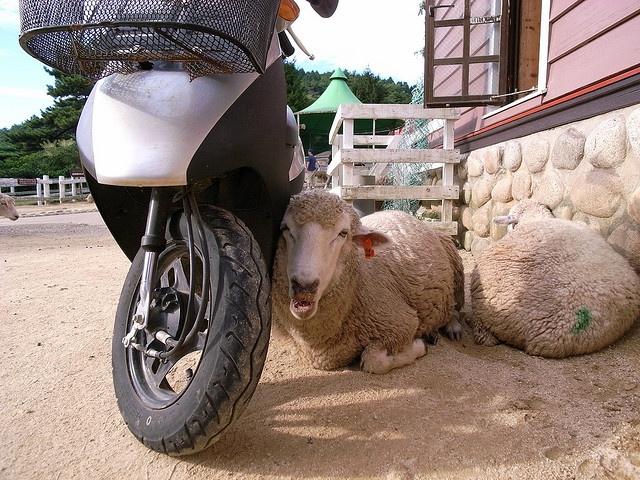Describe the objects in this image and their specific colors. I can see motorcycle in white, black, gray, lavender, and darkgray tones, sheep in white, maroon, and gray tones, sheep in white, gray, darkgray, and tan tones, and people in white, darkgray, navy, and gray tones in this image. 